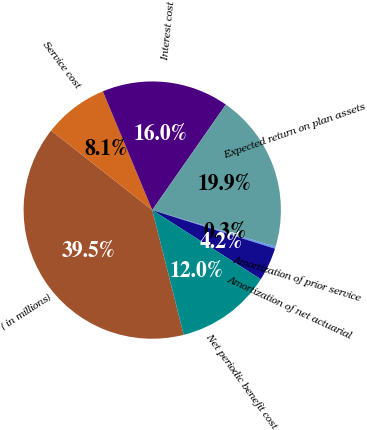Convert chart. <chart><loc_0><loc_0><loc_500><loc_500><pie_chart><fcel>( in millions)<fcel>Service cost<fcel>Interest cost<fcel>Expected return on plan assets<fcel>Amortization of prior service<fcel>Amortization of net actuarial<fcel>Net periodic benefit cost<nl><fcel>39.54%<fcel>8.11%<fcel>15.97%<fcel>19.9%<fcel>0.26%<fcel>4.18%<fcel>12.04%<nl></chart> 